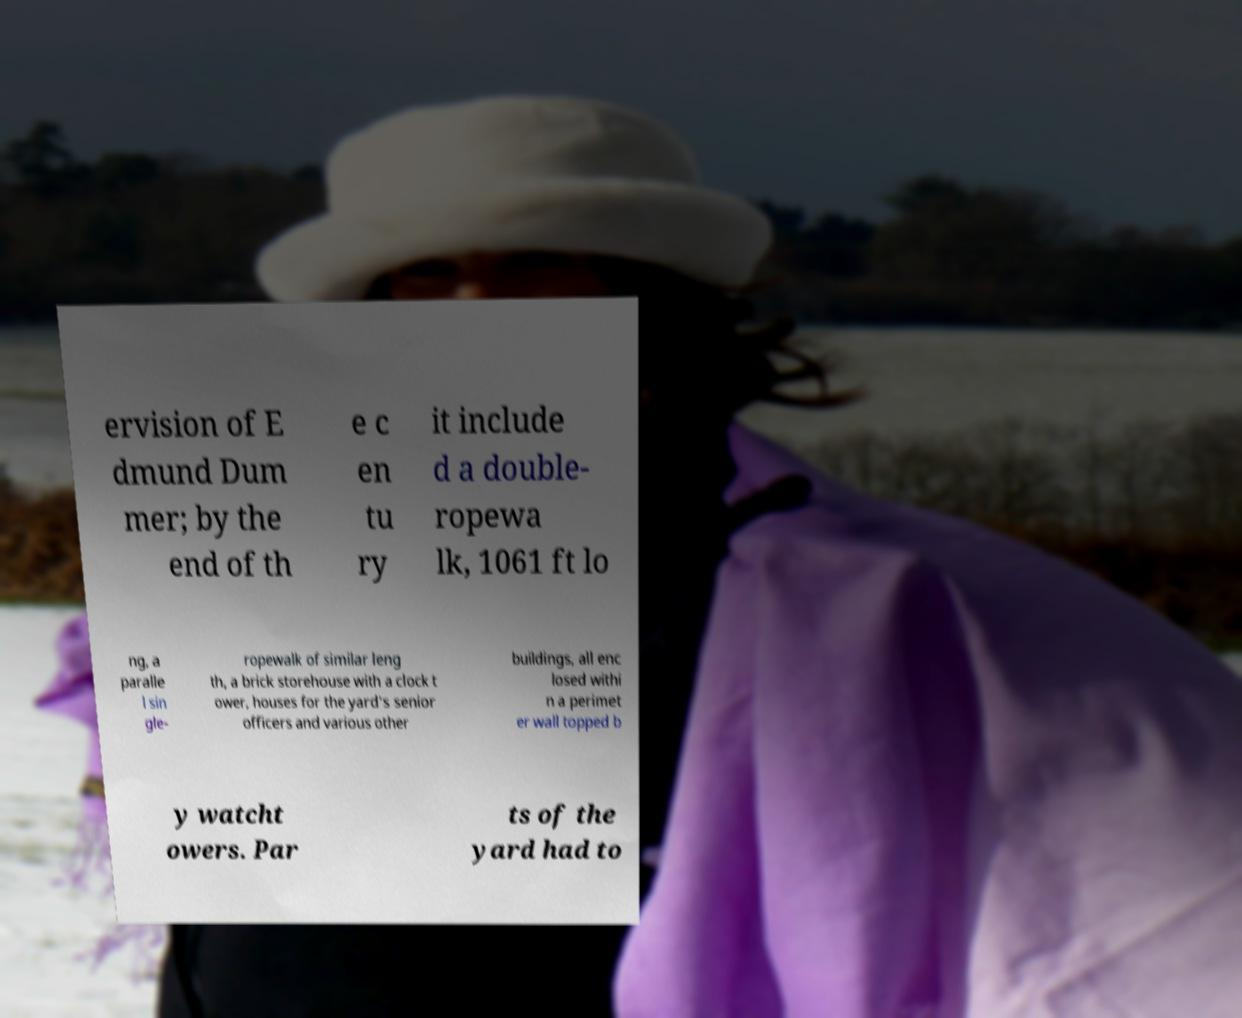There's text embedded in this image that I need extracted. Can you transcribe it verbatim? ervision of E dmund Dum mer; by the end of th e c en tu ry it include d a double- ropewa lk, 1061 ft lo ng, a paralle l sin gle- ropewalk of similar leng th, a brick storehouse with a clock t ower, houses for the yard's senior officers and various other buildings, all enc losed withi n a perimet er wall topped b y watcht owers. Par ts of the yard had to 